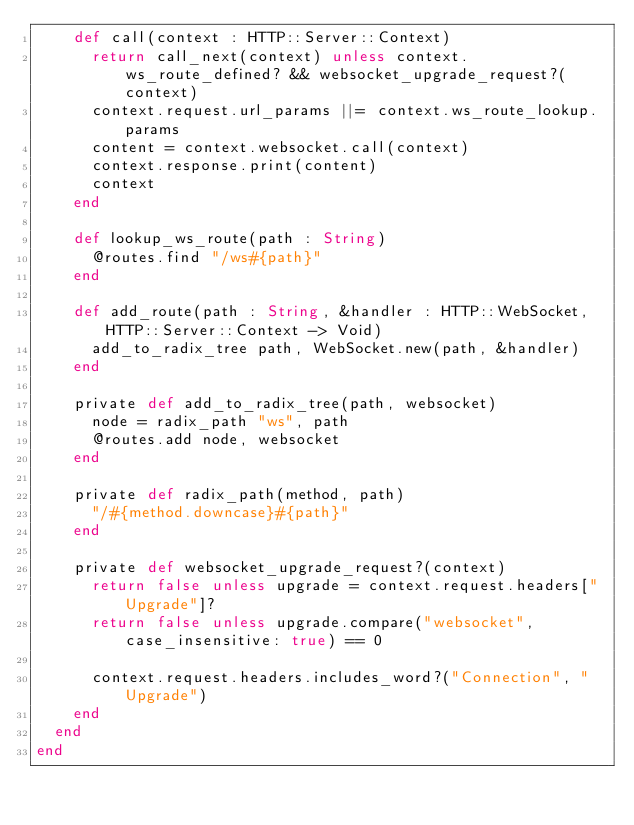Convert code to text. <code><loc_0><loc_0><loc_500><loc_500><_Crystal_>    def call(context : HTTP::Server::Context)
      return call_next(context) unless context.ws_route_defined? && websocket_upgrade_request?(context)
      context.request.url_params ||= context.ws_route_lookup.params
      content = context.websocket.call(context)
      context.response.print(content)
      context
    end

    def lookup_ws_route(path : String)
      @routes.find "/ws#{path}"
    end

    def add_route(path : String, &handler : HTTP::WebSocket, HTTP::Server::Context -> Void)
      add_to_radix_tree path, WebSocket.new(path, &handler)
    end

    private def add_to_radix_tree(path, websocket)
      node = radix_path "ws", path
      @routes.add node, websocket
    end

    private def radix_path(method, path)
      "/#{method.downcase}#{path}"
    end

    private def websocket_upgrade_request?(context)
      return false unless upgrade = context.request.headers["Upgrade"]?
      return false unless upgrade.compare("websocket", case_insensitive: true) == 0

      context.request.headers.includes_word?("Connection", "Upgrade")
    end
  end
end
</code> 